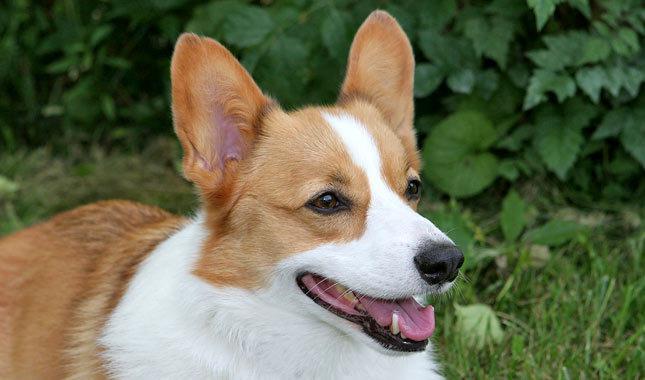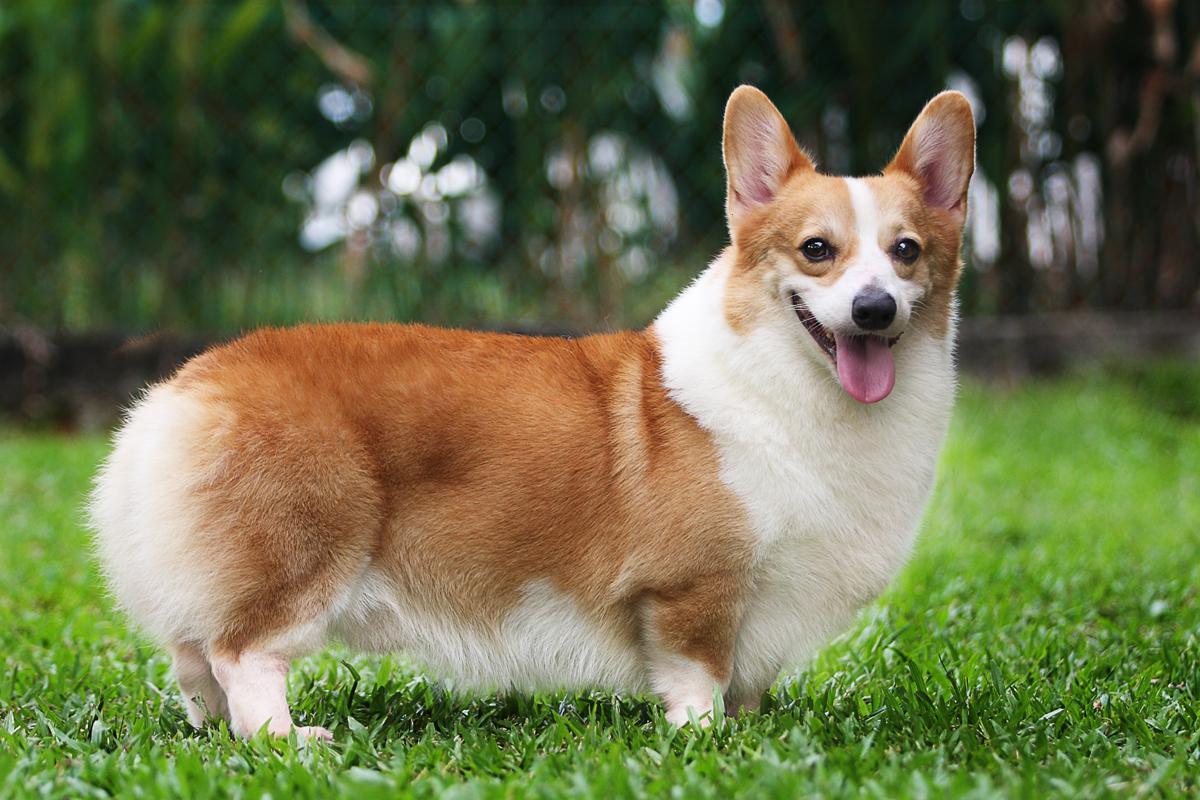The first image is the image on the left, the second image is the image on the right. For the images displayed, is the sentence "One dog is standing on the grass." factually correct? Answer yes or no. Yes. 